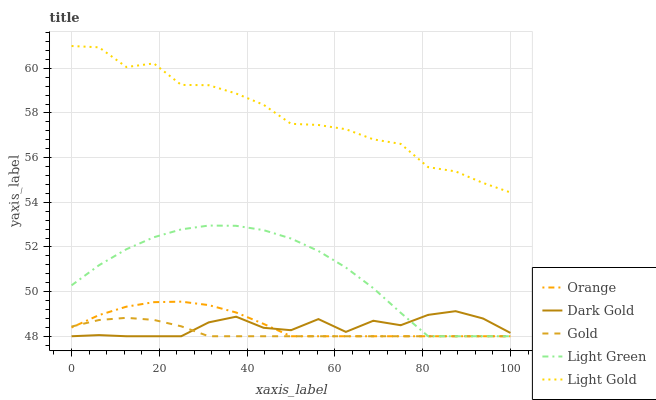Does Gold have the minimum area under the curve?
Answer yes or no. Yes. Does Light Gold have the maximum area under the curve?
Answer yes or no. Yes. Does Light Green have the minimum area under the curve?
Answer yes or no. No. Does Light Green have the maximum area under the curve?
Answer yes or no. No. Is Gold the smoothest?
Answer yes or no. Yes. Is Light Gold the roughest?
Answer yes or no. Yes. Is Light Green the smoothest?
Answer yes or no. No. Is Light Green the roughest?
Answer yes or no. No. Does Orange have the lowest value?
Answer yes or no. Yes. Does Light Gold have the lowest value?
Answer yes or no. No. Does Light Gold have the highest value?
Answer yes or no. Yes. Does Light Green have the highest value?
Answer yes or no. No. Is Light Green less than Light Gold?
Answer yes or no. Yes. Is Light Gold greater than Light Green?
Answer yes or no. Yes. Does Orange intersect Gold?
Answer yes or no. Yes. Is Orange less than Gold?
Answer yes or no. No. Is Orange greater than Gold?
Answer yes or no. No. Does Light Green intersect Light Gold?
Answer yes or no. No. 